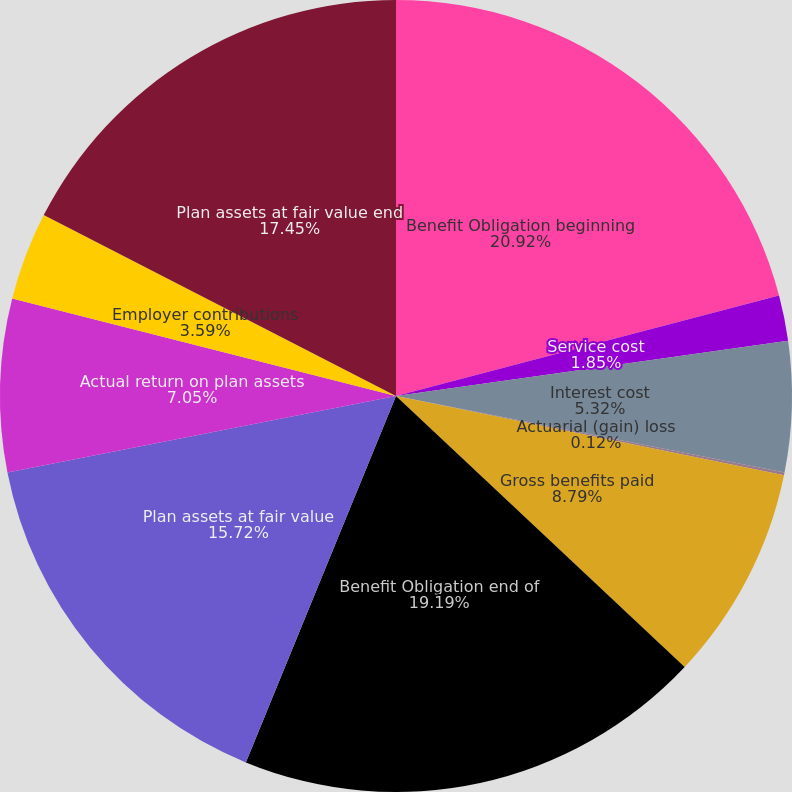<chart> <loc_0><loc_0><loc_500><loc_500><pie_chart><fcel>Benefit Obligation beginning<fcel>Service cost<fcel>Interest cost<fcel>Actuarial (gain) loss<fcel>Gross benefits paid<fcel>Benefit Obligation end of<fcel>Plan assets at fair value<fcel>Actual return on plan assets<fcel>Employer contributions<fcel>Plan assets at fair value end<nl><fcel>20.92%<fcel>1.85%<fcel>5.32%<fcel>0.12%<fcel>8.79%<fcel>19.19%<fcel>15.72%<fcel>7.05%<fcel>3.59%<fcel>17.45%<nl></chart> 